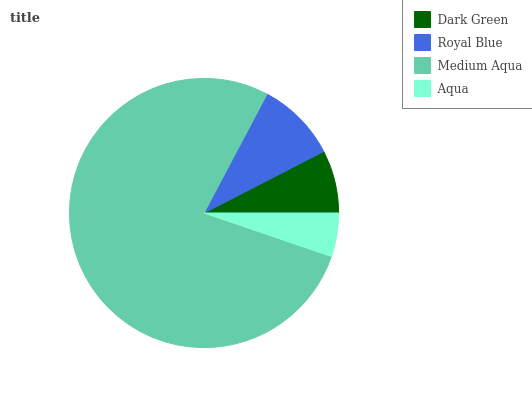Is Aqua the minimum?
Answer yes or no. Yes. Is Medium Aqua the maximum?
Answer yes or no. Yes. Is Royal Blue the minimum?
Answer yes or no. No. Is Royal Blue the maximum?
Answer yes or no. No. Is Royal Blue greater than Dark Green?
Answer yes or no. Yes. Is Dark Green less than Royal Blue?
Answer yes or no. Yes. Is Dark Green greater than Royal Blue?
Answer yes or no. No. Is Royal Blue less than Dark Green?
Answer yes or no. No. Is Royal Blue the high median?
Answer yes or no. Yes. Is Dark Green the low median?
Answer yes or no. Yes. Is Dark Green the high median?
Answer yes or no. No. Is Royal Blue the low median?
Answer yes or no. No. 